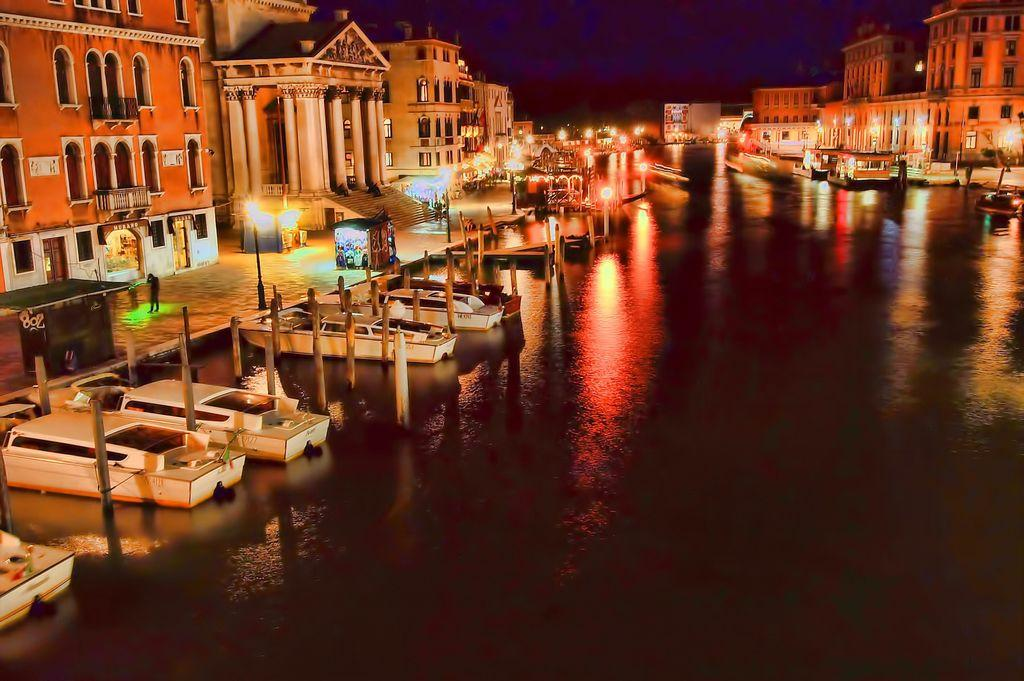What is on the water surface in the image? There are ships on the water surface in the image. What are the people in the image doing? The people in the image are walking on the road. What type of structures can be seen in the image? There are buildings visible in the image. What type of vest is being worn by the jelly in the image? There is no jelly or vest present in the image. What joke is being told by the people walking on the road in the image? There is no joke being told in the image; the people are simply walking on the road. 